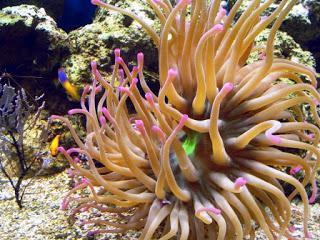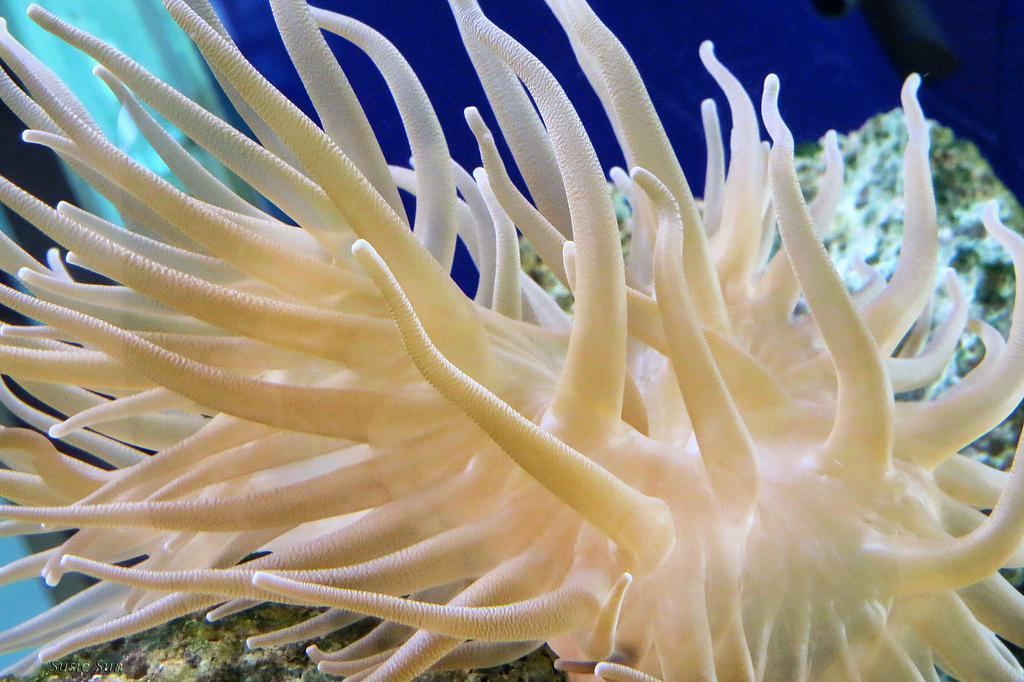The first image is the image on the left, the second image is the image on the right. For the images displayed, is the sentence "At least one anemone is red or green and another is white." factually correct? Answer yes or no. No. The first image is the image on the left, the second image is the image on the right. For the images displayed, is the sentence "The lefthand image contains an anemone with pink bits, the righthand image contains a mostly white anemone." factually correct? Answer yes or no. Yes. 